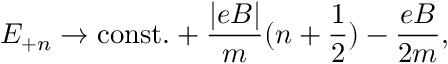<formula> <loc_0><loc_0><loc_500><loc_500>E _ { + n } \rightarrow c o n s t . + \frac { | e B | } { m } ( n + { \frac { 1 } { 2 } } ) - \frac { e B } { 2 m } ,</formula> 